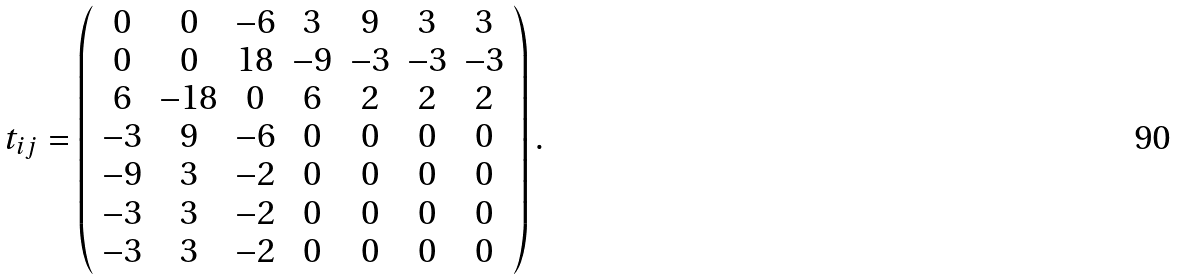Convert formula to latex. <formula><loc_0><loc_0><loc_500><loc_500>t _ { i j } = \left ( \begin{array} { c c c c c c c } 0 & 0 & - 6 & 3 & 9 & 3 & 3 \\ 0 & 0 & 1 8 & - 9 & - 3 & - 3 & - 3 \\ 6 & - 1 8 & 0 & 6 & 2 & 2 & 2 \\ - 3 & 9 & - 6 & 0 & 0 & 0 & 0 \\ - 9 & 3 & - 2 & 0 & 0 & 0 & 0 \\ - 3 & 3 & - 2 & 0 & 0 & 0 & 0 \\ - 3 & 3 & - 2 & 0 & 0 & 0 & 0 \\ \end{array} \right ) .</formula> 